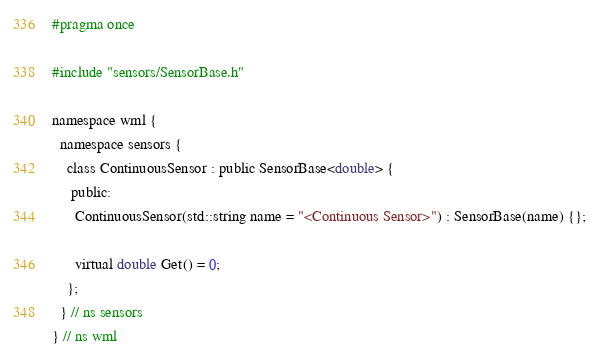Convert code to text. <code><loc_0><loc_0><loc_500><loc_500><_C_>#pragma once

#include "sensors/SensorBase.h"

namespace wml {
  namespace sensors {
    class ContinuousSensor : public SensorBase<double> {
     public:
      ContinuousSensor(std::string name = "<Continuous Sensor>") : SensorBase(name) {};

      virtual double Get() = 0;
    };
  } // ns sensors
} // ns wml
</code> 